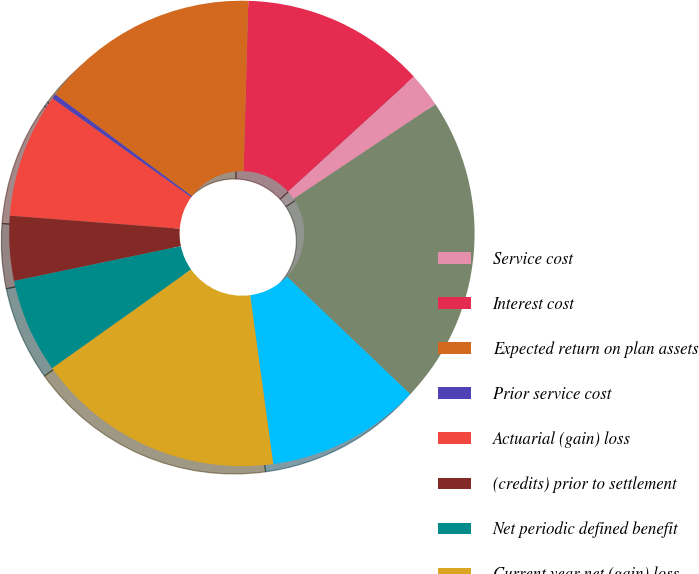Convert chart to OTSL. <chart><loc_0><loc_0><loc_500><loc_500><pie_chart><fcel>Service cost<fcel>Interest cost<fcel>Expected return on plan assets<fcel>Prior service cost<fcel>Actuarial (gain) loss<fcel>(credits) prior to settlement<fcel>Net periodic defined benefit<fcel>Current year net (gain) loss<fcel>Actuarial loss<fcel>Total recognized in OCI and<nl><fcel>2.41%<fcel>12.79%<fcel>15.25%<fcel>0.34%<fcel>8.64%<fcel>4.49%<fcel>6.56%<fcel>17.33%<fcel>10.72%<fcel>21.48%<nl></chart> 